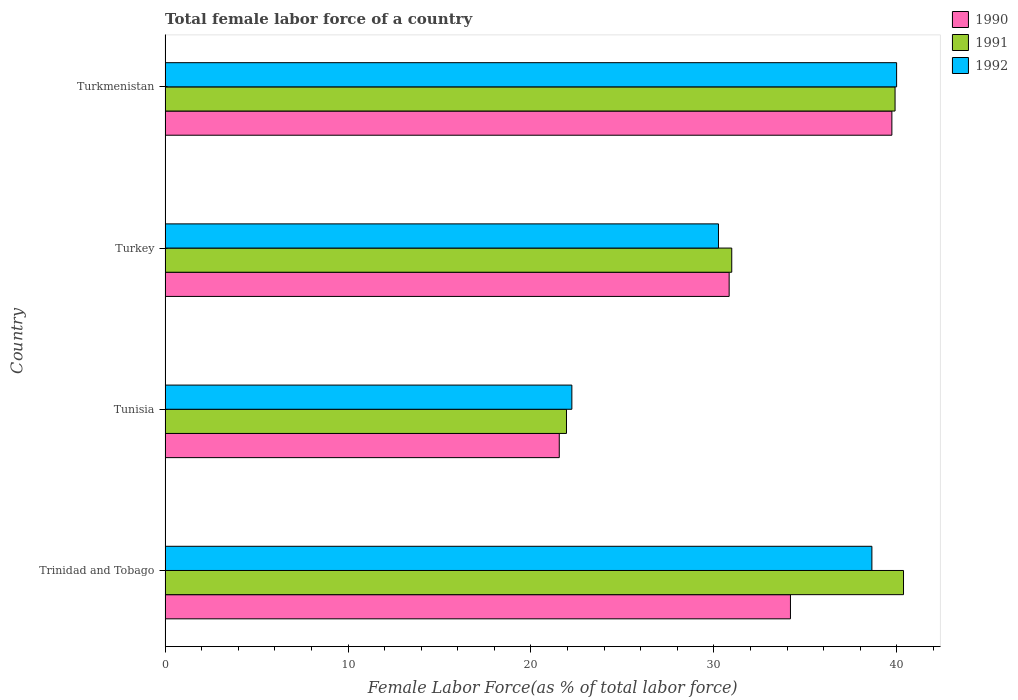How many different coloured bars are there?
Your answer should be very brief. 3. Are the number of bars per tick equal to the number of legend labels?
Provide a succinct answer. Yes. Are the number of bars on each tick of the Y-axis equal?
Give a very brief answer. Yes. How many bars are there on the 3rd tick from the bottom?
Offer a very short reply. 3. What is the label of the 1st group of bars from the top?
Keep it short and to the point. Turkmenistan. In how many cases, is the number of bars for a given country not equal to the number of legend labels?
Offer a terse response. 0. What is the percentage of female labor force in 1990 in Trinidad and Tobago?
Ensure brevity in your answer.  34.18. Across all countries, what is the maximum percentage of female labor force in 1991?
Give a very brief answer. 40.37. Across all countries, what is the minimum percentage of female labor force in 1992?
Your answer should be compact. 22.24. In which country was the percentage of female labor force in 1991 maximum?
Your answer should be compact. Trinidad and Tobago. In which country was the percentage of female labor force in 1991 minimum?
Offer a terse response. Tunisia. What is the total percentage of female labor force in 1990 in the graph?
Offer a very short reply. 126.3. What is the difference between the percentage of female labor force in 1990 in Tunisia and that in Turkey?
Provide a short and direct response. -9.29. What is the difference between the percentage of female labor force in 1991 in Trinidad and Tobago and the percentage of female labor force in 1992 in Turkey?
Provide a short and direct response. 10.12. What is the average percentage of female labor force in 1992 per country?
Offer a terse response. 32.78. What is the difference between the percentage of female labor force in 1992 and percentage of female labor force in 1991 in Tunisia?
Make the answer very short. 0.29. In how many countries, is the percentage of female labor force in 1990 greater than 16 %?
Ensure brevity in your answer.  4. What is the ratio of the percentage of female labor force in 1992 in Trinidad and Tobago to that in Turkmenistan?
Make the answer very short. 0.97. Is the difference between the percentage of female labor force in 1992 in Tunisia and Turkey greater than the difference between the percentage of female labor force in 1991 in Tunisia and Turkey?
Offer a terse response. Yes. What is the difference between the highest and the second highest percentage of female labor force in 1991?
Ensure brevity in your answer.  0.46. What is the difference between the highest and the lowest percentage of female labor force in 1990?
Keep it short and to the point. 18.18. In how many countries, is the percentage of female labor force in 1992 greater than the average percentage of female labor force in 1992 taken over all countries?
Your answer should be compact. 2. What does the 1st bar from the top in Tunisia represents?
Give a very brief answer. 1992. Is it the case that in every country, the sum of the percentage of female labor force in 1990 and percentage of female labor force in 1992 is greater than the percentage of female labor force in 1991?
Provide a succinct answer. Yes. How many bars are there?
Provide a succinct answer. 12. Are all the bars in the graph horizontal?
Give a very brief answer. Yes. How many countries are there in the graph?
Your answer should be very brief. 4. Are the values on the major ticks of X-axis written in scientific E-notation?
Ensure brevity in your answer.  No. What is the title of the graph?
Make the answer very short. Total female labor force of a country. Does "1964" appear as one of the legend labels in the graph?
Ensure brevity in your answer.  No. What is the label or title of the X-axis?
Keep it short and to the point. Female Labor Force(as % of total labor force). What is the Female Labor Force(as % of total labor force) in 1990 in Trinidad and Tobago?
Keep it short and to the point. 34.18. What is the Female Labor Force(as % of total labor force) in 1991 in Trinidad and Tobago?
Make the answer very short. 40.37. What is the Female Labor Force(as % of total labor force) of 1992 in Trinidad and Tobago?
Offer a terse response. 38.64. What is the Female Labor Force(as % of total labor force) of 1990 in Tunisia?
Give a very brief answer. 21.55. What is the Female Labor Force(as % of total labor force) in 1991 in Tunisia?
Give a very brief answer. 21.94. What is the Female Labor Force(as % of total labor force) of 1992 in Tunisia?
Provide a short and direct response. 22.24. What is the Female Labor Force(as % of total labor force) in 1990 in Turkey?
Your answer should be very brief. 30.83. What is the Female Labor Force(as % of total labor force) of 1991 in Turkey?
Ensure brevity in your answer.  30.98. What is the Female Labor Force(as % of total labor force) in 1992 in Turkey?
Ensure brevity in your answer.  30.25. What is the Female Labor Force(as % of total labor force) of 1990 in Turkmenistan?
Your answer should be very brief. 39.73. What is the Female Labor Force(as % of total labor force) in 1991 in Turkmenistan?
Your response must be concise. 39.9. What is the Female Labor Force(as % of total labor force) of 1992 in Turkmenistan?
Offer a very short reply. 39.99. Across all countries, what is the maximum Female Labor Force(as % of total labor force) in 1990?
Provide a succinct answer. 39.73. Across all countries, what is the maximum Female Labor Force(as % of total labor force) of 1991?
Make the answer very short. 40.37. Across all countries, what is the maximum Female Labor Force(as % of total labor force) in 1992?
Provide a short and direct response. 39.99. Across all countries, what is the minimum Female Labor Force(as % of total labor force) of 1990?
Make the answer very short. 21.55. Across all countries, what is the minimum Female Labor Force(as % of total labor force) of 1991?
Offer a terse response. 21.94. Across all countries, what is the minimum Female Labor Force(as % of total labor force) of 1992?
Provide a succinct answer. 22.24. What is the total Female Labor Force(as % of total labor force) in 1990 in the graph?
Your response must be concise. 126.3. What is the total Female Labor Force(as % of total labor force) in 1991 in the graph?
Offer a terse response. 133.19. What is the total Female Labor Force(as % of total labor force) in 1992 in the graph?
Make the answer very short. 131.11. What is the difference between the Female Labor Force(as % of total labor force) of 1990 in Trinidad and Tobago and that in Tunisia?
Keep it short and to the point. 12.64. What is the difference between the Female Labor Force(as % of total labor force) of 1991 in Trinidad and Tobago and that in Tunisia?
Your answer should be compact. 18.42. What is the difference between the Female Labor Force(as % of total labor force) in 1992 in Trinidad and Tobago and that in Tunisia?
Your answer should be compact. 16.4. What is the difference between the Female Labor Force(as % of total labor force) in 1990 in Trinidad and Tobago and that in Turkey?
Your response must be concise. 3.35. What is the difference between the Female Labor Force(as % of total labor force) in 1991 in Trinidad and Tobago and that in Turkey?
Provide a short and direct response. 9.39. What is the difference between the Female Labor Force(as % of total labor force) in 1992 in Trinidad and Tobago and that in Turkey?
Offer a very short reply. 8.39. What is the difference between the Female Labor Force(as % of total labor force) of 1990 in Trinidad and Tobago and that in Turkmenistan?
Offer a very short reply. -5.54. What is the difference between the Female Labor Force(as % of total labor force) of 1991 in Trinidad and Tobago and that in Turkmenistan?
Make the answer very short. 0.46. What is the difference between the Female Labor Force(as % of total labor force) in 1992 in Trinidad and Tobago and that in Turkmenistan?
Your answer should be compact. -1.35. What is the difference between the Female Labor Force(as % of total labor force) in 1990 in Tunisia and that in Turkey?
Give a very brief answer. -9.29. What is the difference between the Female Labor Force(as % of total labor force) in 1991 in Tunisia and that in Turkey?
Keep it short and to the point. -9.03. What is the difference between the Female Labor Force(as % of total labor force) in 1992 in Tunisia and that in Turkey?
Ensure brevity in your answer.  -8.01. What is the difference between the Female Labor Force(as % of total labor force) of 1990 in Tunisia and that in Turkmenistan?
Your response must be concise. -18.18. What is the difference between the Female Labor Force(as % of total labor force) of 1991 in Tunisia and that in Turkmenistan?
Your answer should be very brief. -17.96. What is the difference between the Female Labor Force(as % of total labor force) of 1992 in Tunisia and that in Turkmenistan?
Offer a very short reply. -17.75. What is the difference between the Female Labor Force(as % of total labor force) in 1990 in Turkey and that in Turkmenistan?
Give a very brief answer. -8.89. What is the difference between the Female Labor Force(as % of total labor force) in 1991 in Turkey and that in Turkmenistan?
Offer a very short reply. -8.93. What is the difference between the Female Labor Force(as % of total labor force) of 1992 in Turkey and that in Turkmenistan?
Your response must be concise. -9.74. What is the difference between the Female Labor Force(as % of total labor force) of 1990 in Trinidad and Tobago and the Female Labor Force(as % of total labor force) of 1991 in Tunisia?
Keep it short and to the point. 12.24. What is the difference between the Female Labor Force(as % of total labor force) of 1990 in Trinidad and Tobago and the Female Labor Force(as % of total labor force) of 1992 in Tunisia?
Your response must be concise. 11.95. What is the difference between the Female Labor Force(as % of total labor force) in 1991 in Trinidad and Tobago and the Female Labor Force(as % of total labor force) in 1992 in Tunisia?
Keep it short and to the point. 18.13. What is the difference between the Female Labor Force(as % of total labor force) in 1990 in Trinidad and Tobago and the Female Labor Force(as % of total labor force) in 1991 in Turkey?
Ensure brevity in your answer.  3.21. What is the difference between the Female Labor Force(as % of total labor force) of 1990 in Trinidad and Tobago and the Female Labor Force(as % of total labor force) of 1992 in Turkey?
Your response must be concise. 3.94. What is the difference between the Female Labor Force(as % of total labor force) of 1991 in Trinidad and Tobago and the Female Labor Force(as % of total labor force) of 1992 in Turkey?
Keep it short and to the point. 10.12. What is the difference between the Female Labor Force(as % of total labor force) in 1990 in Trinidad and Tobago and the Female Labor Force(as % of total labor force) in 1991 in Turkmenistan?
Provide a succinct answer. -5.72. What is the difference between the Female Labor Force(as % of total labor force) in 1990 in Trinidad and Tobago and the Female Labor Force(as % of total labor force) in 1992 in Turkmenistan?
Make the answer very short. -5.8. What is the difference between the Female Labor Force(as % of total labor force) of 1991 in Trinidad and Tobago and the Female Labor Force(as % of total labor force) of 1992 in Turkmenistan?
Offer a terse response. 0.38. What is the difference between the Female Labor Force(as % of total labor force) in 1990 in Tunisia and the Female Labor Force(as % of total labor force) in 1991 in Turkey?
Your response must be concise. -9.43. What is the difference between the Female Labor Force(as % of total labor force) in 1990 in Tunisia and the Female Labor Force(as % of total labor force) in 1992 in Turkey?
Provide a short and direct response. -8.7. What is the difference between the Female Labor Force(as % of total labor force) of 1991 in Tunisia and the Female Labor Force(as % of total labor force) of 1992 in Turkey?
Offer a terse response. -8.31. What is the difference between the Female Labor Force(as % of total labor force) in 1990 in Tunisia and the Female Labor Force(as % of total labor force) in 1991 in Turkmenistan?
Offer a very short reply. -18.36. What is the difference between the Female Labor Force(as % of total labor force) in 1990 in Tunisia and the Female Labor Force(as % of total labor force) in 1992 in Turkmenistan?
Your answer should be compact. -18.44. What is the difference between the Female Labor Force(as % of total labor force) in 1991 in Tunisia and the Female Labor Force(as % of total labor force) in 1992 in Turkmenistan?
Your response must be concise. -18.05. What is the difference between the Female Labor Force(as % of total labor force) of 1990 in Turkey and the Female Labor Force(as % of total labor force) of 1991 in Turkmenistan?
Provide a succinct answer. -9.07. What is the difference between the Female Labor Force(as % of total labor force) of 1990 in Turkey and the Female Labor Force(as % of total labor force) of 1992 in Turkmenistan?
Offer a very short reply. -9.15. What is the difference between the Female Labor Force(as % of total labor force) in 1991 in Turkey and the Female Labor Force(as % of total labor force) in 1992 in Turkmenistan?
Give a very brief answer. -9.01. What is the average Female Labor Force(as % of total labor force) of 1990 per country?
Your answer should be compact. 31.57. What is the average Female Labor Force(as % of total labor force) in 1991 per country?
Offer a terse response. 33.3. What is the average Female Labor Force(as % of total labor force) in 1992 per country?
Keep it short and to the point. 32.78. What is the difference between the Female Labor Force(as % of total labor force) of 1990 and Female Labor Force(as % of total labor force) of 1991 in Trinidad and Tobago?
Offer a terse response. -6.18. What is the difference between the Female Labor Force(as % of total labor force) of 1990 and Female Labor Force(as % of total labor force) of 1992 in Trinidad and Tobago?
Give a very brief answer. -4.45. What is the difference between the Female Labor Force(as % of total labor force) of 1991 and Female Labor Force(as % of total labor force) of 1992 in Trinidad and Tobago?
Your response must be concise. 1.73. What is the difference between the Female Labor Force(as % of total labor force) of 1990 and Female Labor Force(as % of total labor force) of 1991 in Tunisia?
Your answer should be very brief. -0.39. What is the difference between the Female Labor Force(as % of total labor force) of 1990 and Female Labor Force(as % of total labor force) of 1992 in Tunisia?
Provide a short and direct response. -0.69. What is the difference between the Female Labor Force(as % of total labor force) of 1991 and Female Labor Force(as % of total labor force) of 1992 in Tunisia?
Your response must be concise. -0.29. What is the difference between the Female Labor Force(as % of total labor force) in 1990 and Female Labor Force(as % of total labor force) in 1991 in Turkey?
Give a very brief answer. -0.14. What is the difference between the Female Labor Force(as % of total labor force) in 1990 and Female Labor Force(as % of total labor force) in 1992 in Turkey?
Make the answer very short. 0.58. What is the difference between the Female Labor Force(as % of total labor force) in 1991 and Female Labor Force(as % of total labor force) in 1992 in Turkey?
Ensure brevity in your answer.  0.73. What is the difference between the Female Labor Force(as % of total labor force) of 1990 and Female Labor Force(as % of total labor force) of 1991 in Turkmenistan?
Your answer should be compact. -0.17. What is the difference between the Female Labor Force(as % of total labor force) in 1990 and Female Labor Force(as % of total labor force) in 1992 in Turkmenistan?
Your answer should be very brief. -0.26. What is the difference between the Female Labor Force(as % of total labor force) in 1991 and Female Labor Force(as % of total labor force) in 1992 in Turkmenistan?
Provide a succinct answer. -0.09. What is the ratio of the Female Labor Force(as % of total labor force) in 1990 in Trinidad and Tobago to that in Tunisia?
Provide a short and direct response. 1.59. What is the ratio of the Female Labor Force(as % of total labor force) of 1991 in Trinidad and Tobago to that in Tunisia?
Give a very brief answer. 1.84. What is the ratio of the Female Labor Force(as % of total labor force) in 1992 in Trinidad and Tobago to that in Tunisia?
Your response must be concise. 1.74. What is the ratio of the Female Labor Force(as % of total labor force) of 1990 in Trinidad and Tobago to that in Turkey?
Offer a very short reply. 1.11. What is the ratio of the Female Labor Force(as % of total labor force) of 1991 in Trinidad and Tobago to that in Turkey?
Provide a short and direct response. 1.3. What is the ratio of the Female Labor Force(as % of total labor force) of 1992 in Trinidad and Tobago to that in Turkey?
Keep it short and to the point. 1.28. What is the ratio of the Female Labor Force(as % of total labor force) of 1990 in Trinidad and Tobago to that in Turkmenistan?
Make the answer very short. 0.86. What is the ratio of the Female Labor Force(as % of total labor force) in 1991 in Trinidad and Tobago to that in Turkmenistan?
Ensure brevity in your answer.  1.01. What is the ratio of the Female Labor Force(as % of total labor force) in 1992 in Trinidad and Tobago to that in Turkmenistan?
Keep it short and to the point. 0.97. What is the ratio of the Female Labor Force(as % of total labor force) in 1990 in Tunisia to that in Turkey?
Offer a terse response. 0.7. What is the ratio of the Female Labor Force(as % of total labor force) in 1991 in Tunisia to that in Turkey?
Provide a short and direct response. 0.71. What is the ratio of the Female Labor Force(as % of total labor force) in 1992 in Tunisia to that in Turkey?
Ensure brevity in your answer.  0.74. What is the ratio of the Female Labor Force(as % of total labor force) in 1990 in Tunisia to that in Turkmenistan?
Keep it short and to the point. 0.54. What is the ratio of the Female Labor Force(as % of total labor force) of 1991 in Tunisia to that in Turkmenistan?
Ensure brevity in your answer.  0.55. What is the ratio of the Female Labor Force(as % of total labor force) in 1992 in Tunisia to that in Turkmenistan?
Give a very brief answer. 0.56. What is the ratio of the Female Labor Force(as % of total labor force) in 1990 in Turkey to that in Turkmenistan?
Your answer should be compact. 0.78. What is the ratio of the Female Labor Force(as % of total labor force) in 1991 in Turkey to that in Turkmenistan?
Provide a short and direct response. 0.78. What is the ratio of the Female Labor Force(as % of total labor force) of 1992 in Turkey to that in Turkmenistan?
Offer a very short reply. 0.76. What is the difference between the highest and the second highest Female Labor Force(as % of total labor force) of 1990?
Your answer should be compact. 5.54. What is the difference between the highest and the second highest Female Labor Force(as % of total labor force) in 1991?
Offer a very short reply. 0.46. What is the difference between the highest and the second highest Female Labor Force(as % of total labor force) in 1992?
Make the answer very short. 1.35. What is the difference between the highest and the lowest Female Labor Force(as % of total labor force) of 1990?
Give a very brief answer. 18.18. What is the difference between the highest and the lowest Female Labor Force(as % of total labor force) of 1991?
Give a very brief answer. 18.42. What is the difference between the highest and the lowest Female Labor Force(as % of total labor force) of 1992?
Your answer should be compact. 17.75. 